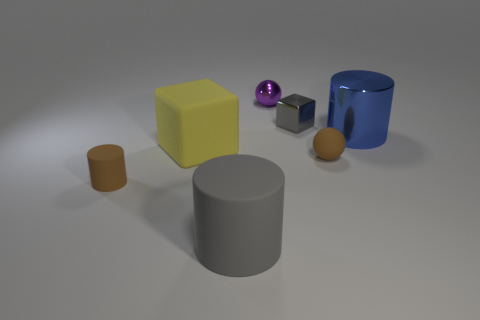What materials do the objects in the image appear to be made of? The objects in the image appear to be made of various materials. The large cylinder looks like it's made of a matte metal or plastic, the small brown cylinder could be made of wood or a wood-imitating material, and the matte yellow cube might be plastic. There's a shiny purple sphere that seems metallic, a smaller metallic cube, and a translucent blue cylinder that gives the impression of being made from glass or a transparent plastic. 